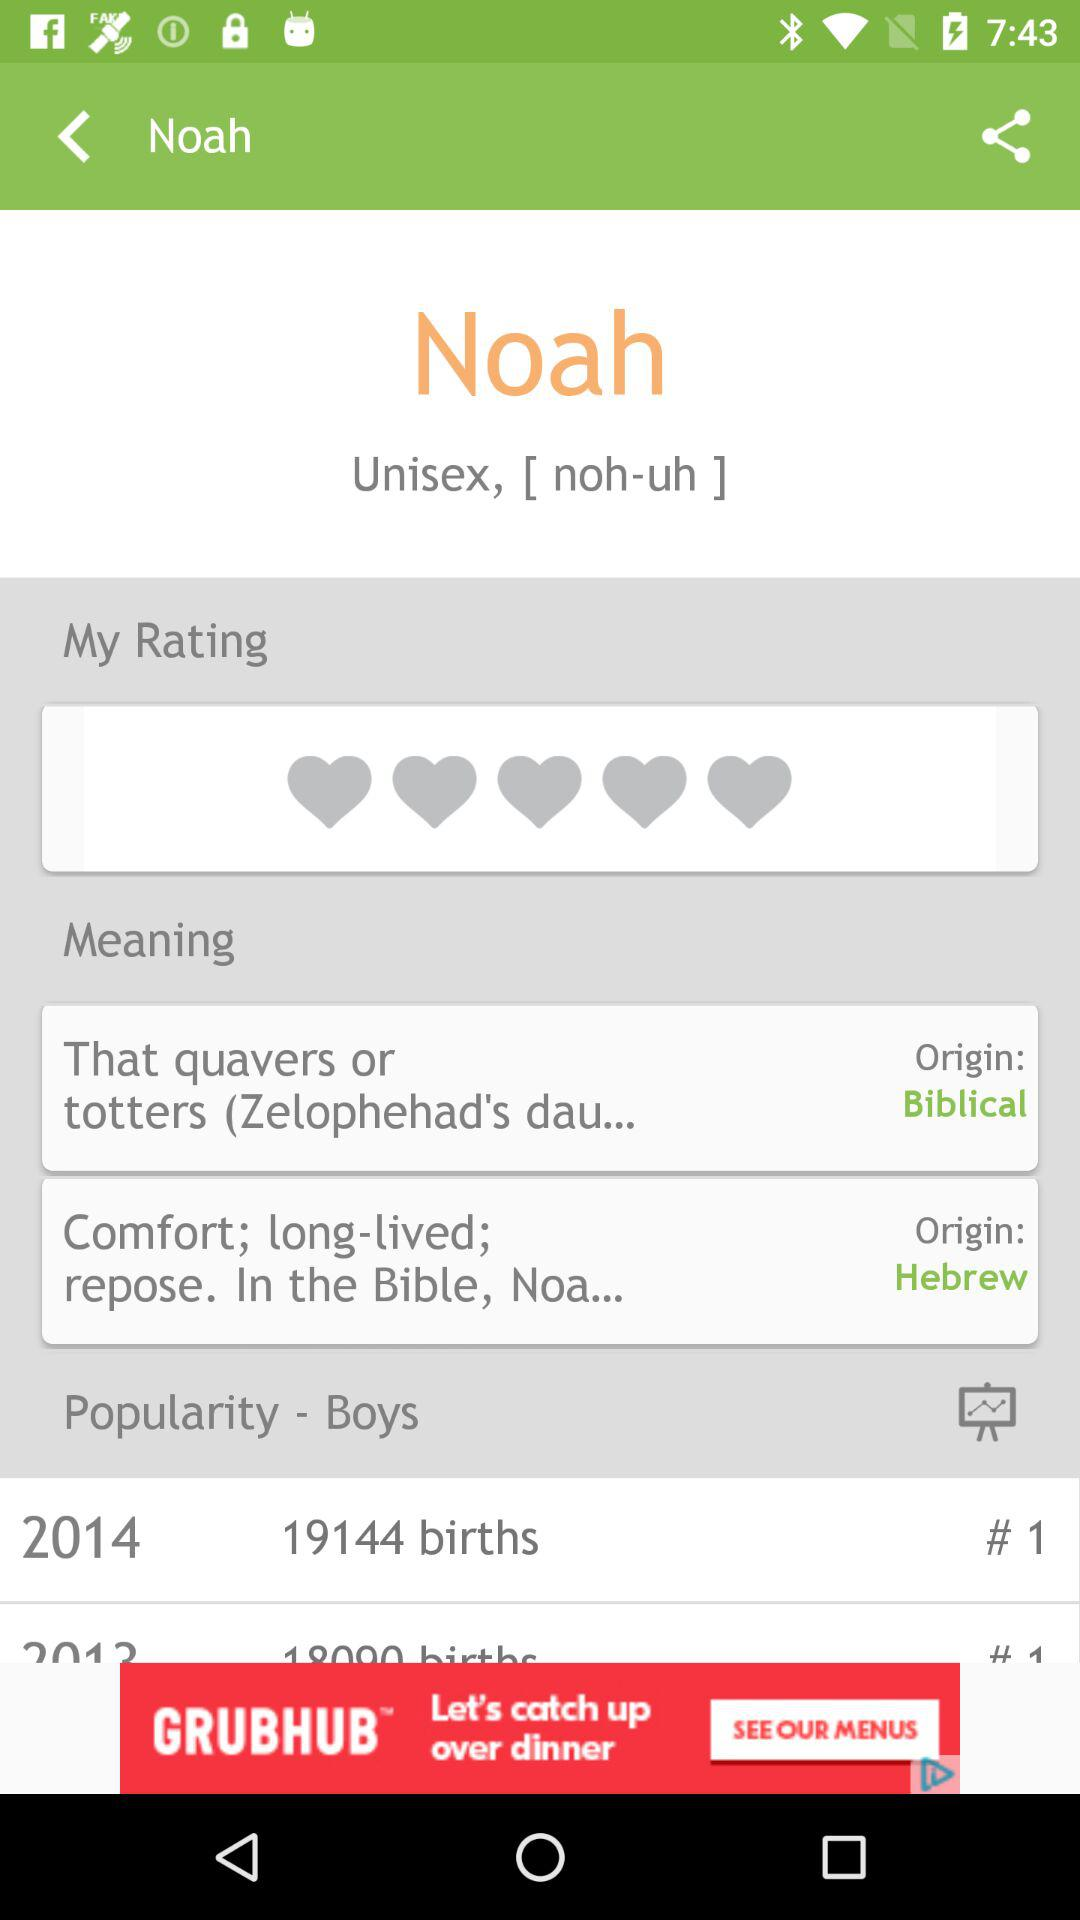What is the origin of "that quavers or totters"? The origin of "that quavers or totters" is Biblical. 